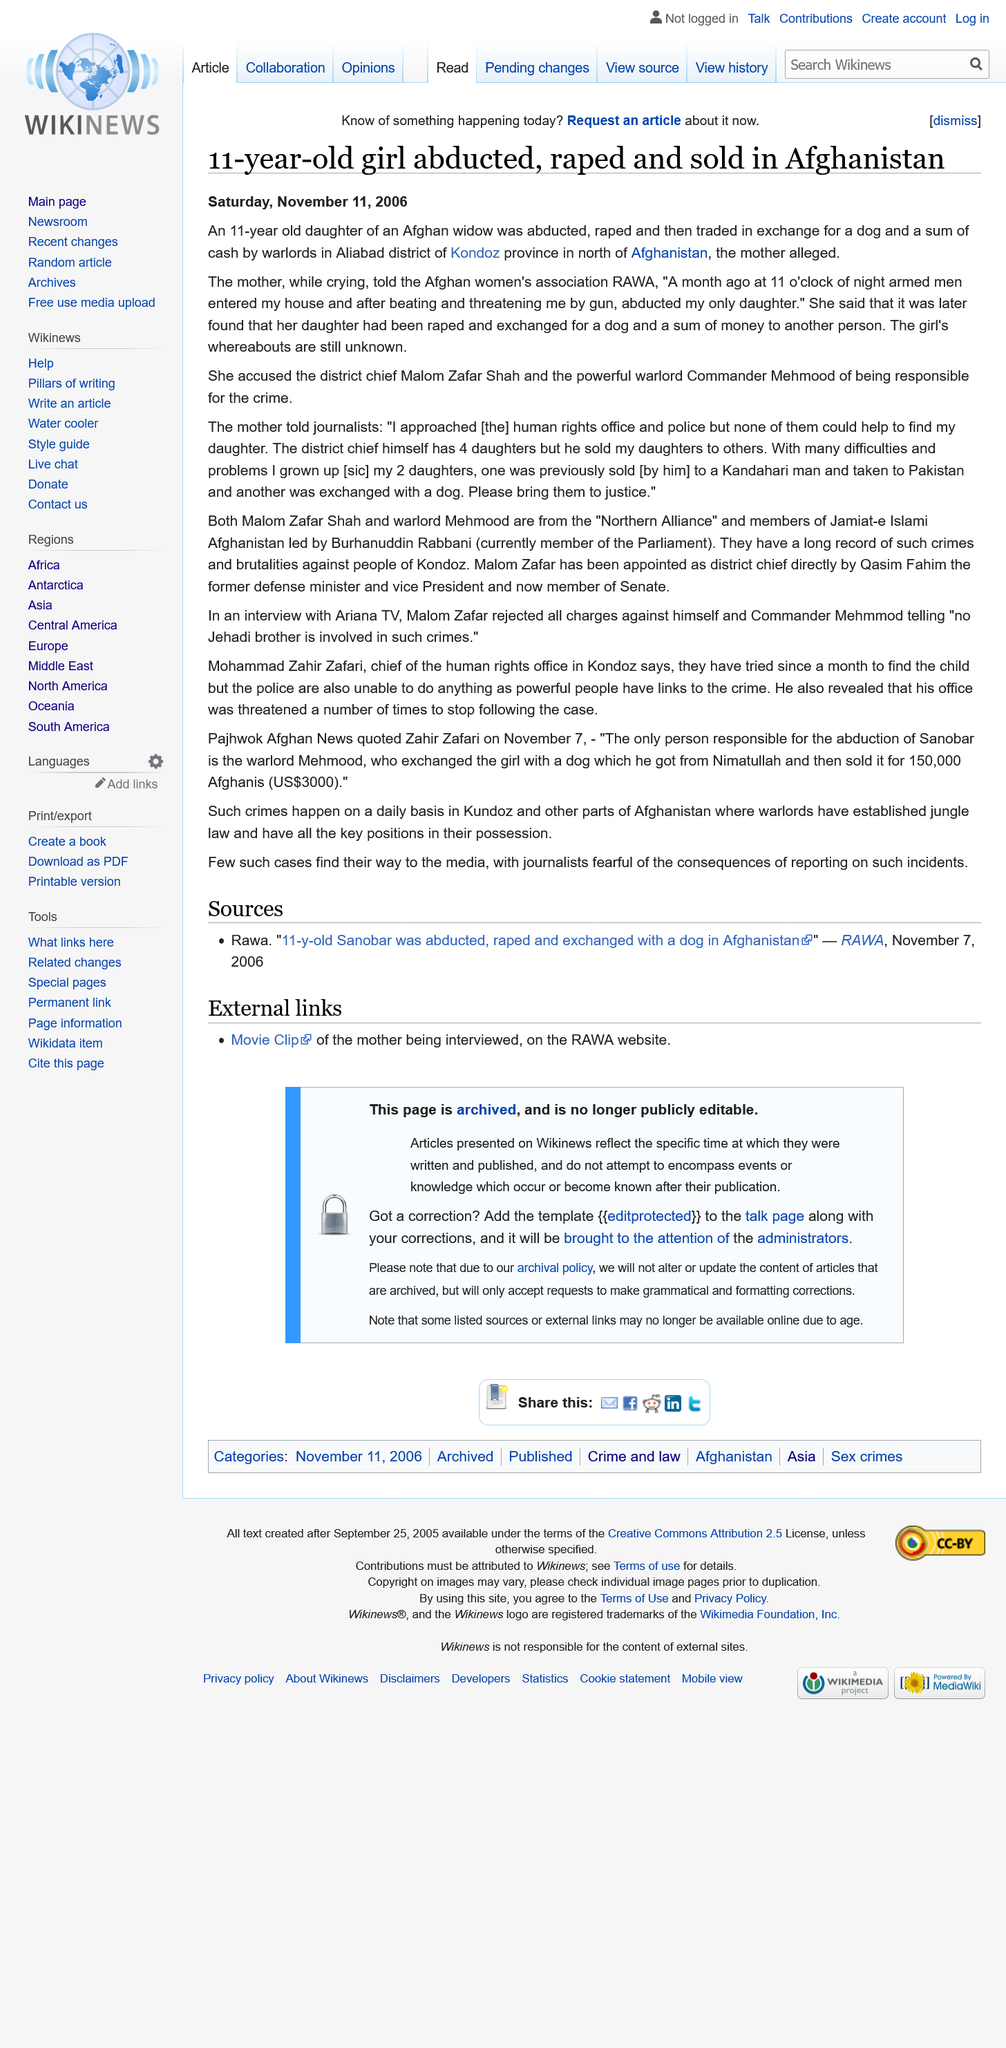Mention a couple of crucial points in this snapshot. The mother of the girl has accused Malom Zafar Shah and Commander Mehmood of the crime. These two individuals are the mother's daughter's alleged perpetrators. The abduction and rape are alleged to have taken place in the Aliabad district of Kondoz province. 